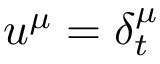<formula> <loc_0><loc_0><loc_500><loc_500>u ^ { \mu } = \delta _ { t } ^ { \mu }</formula> 